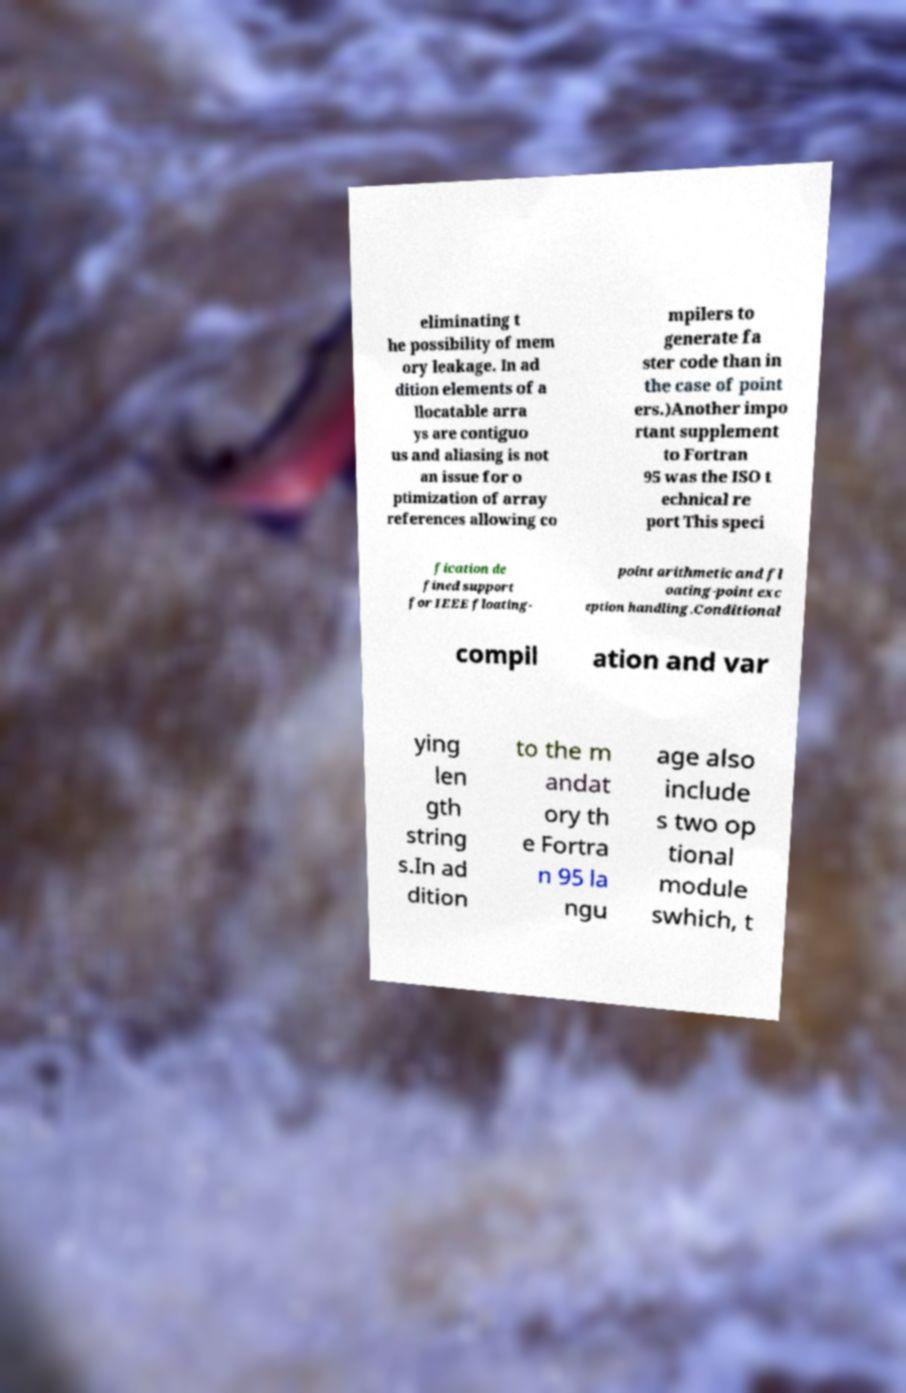For documentation purposes, I need the text within this image transcribed. Could you provide that? eliminating t he possibility of mem ory leakage. In ad dition elements of a llocatable arra ys are contiguo us and aliasing is not an issue for o ptimization of array references allowing co mpilers to generate fa ster code than in the case of point ers.)Another impo rtant supplement to Fortran 95 was the ISO t echnical re port This speci fication de fined support for IEEE floating- point arithmetic and fl oating-point exc eption handling.Conditional compil ation and var ying len gth string s.In ad dition to the m andat ory th e Fortra n 95 la ngu age also include s two op tional module swhich, t 